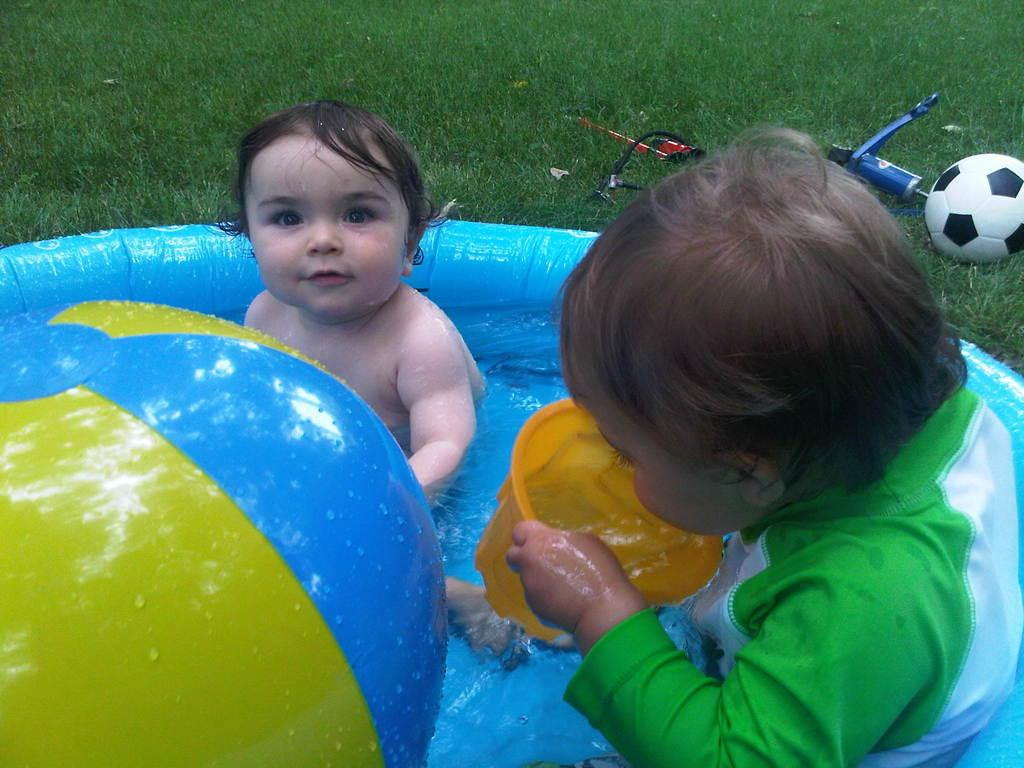What are the kids doing in the image? The kids are playing in a water tub. What other object can be seen in the image besides the kids? There is a mug in the image. What type of surface is visible in the image? There is grass in the image. How many objects that resemble bottles are present in the image? There are two objects that resemble bottles in the image. What type of prose is being recited by the cabbage in the image? There is no cabbage present in the image, and therefore no prose being recited. 